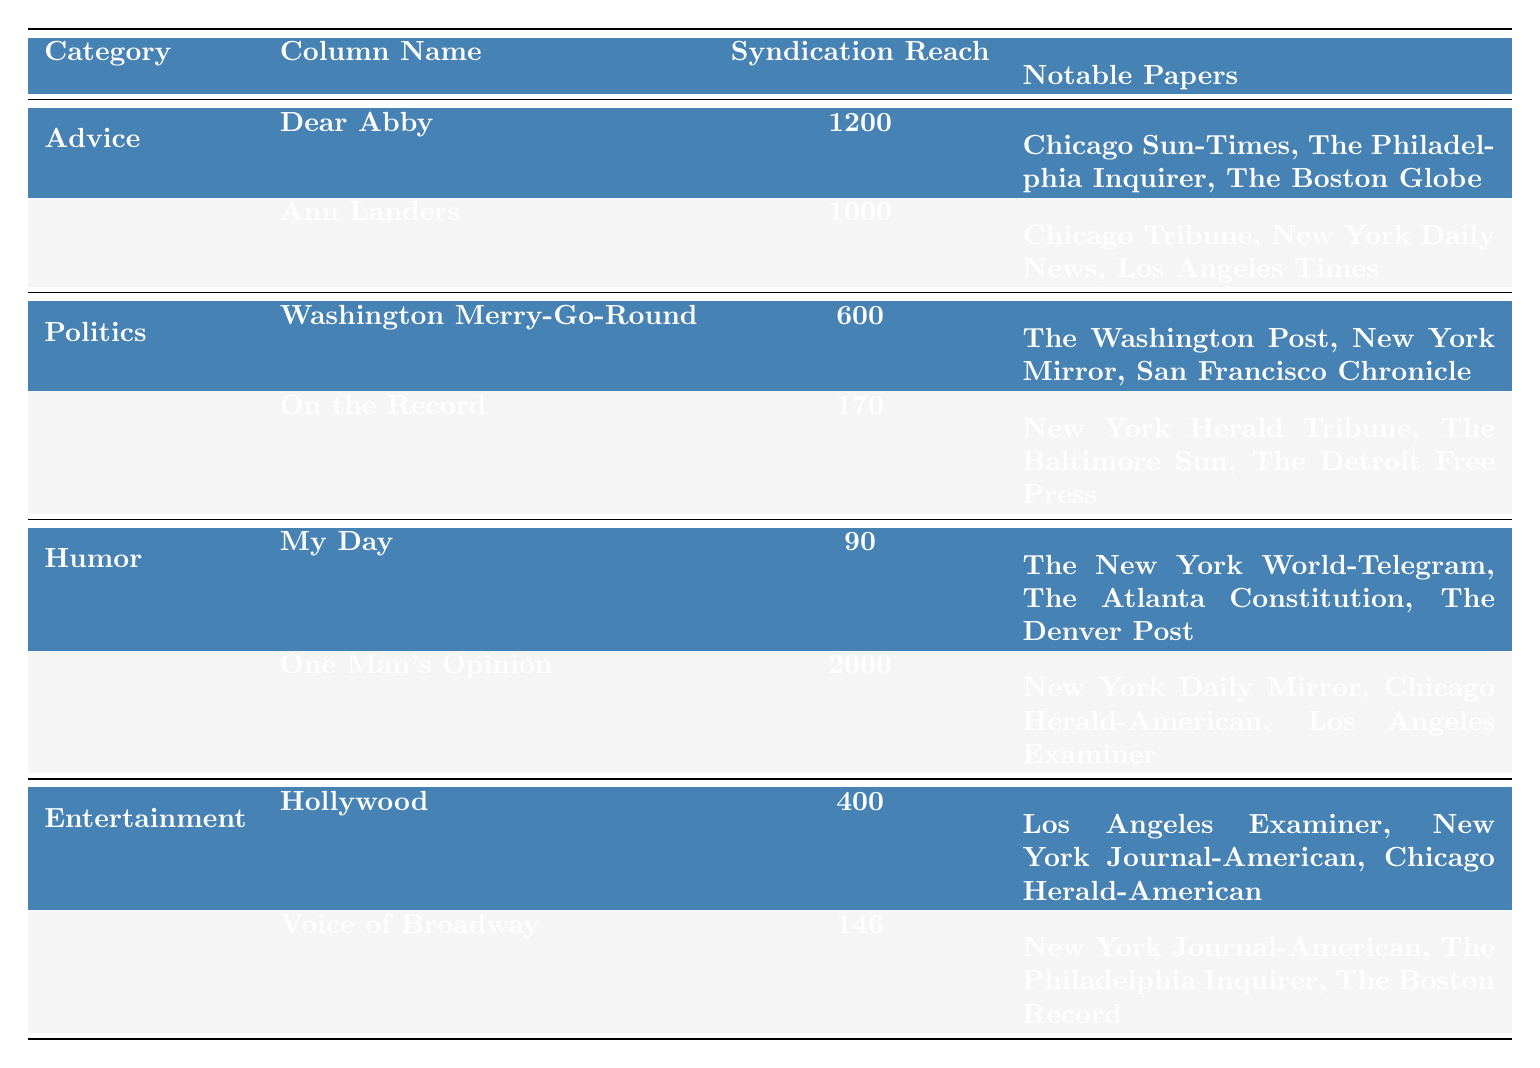What is the syndication reach of "Dear Abby"? From the table, the syndication reach for "Dear Abby" is listed directly as 1200.
Answer: 1200 Which column has the highest syndication reach? By comparing the values in the "Syndication Reach" column, "One Man's Opinion" has the highest at 2000.
Answer: One Man's Opinion How many notable papers are associated with "Washington Merry-Go-Round"? The table lists three notable papers for "Washington Merry-Go-Round": The Washington Post, New York Mirror, San Francisco Chronicle.
Answer: 3 Is "Ann Landers" listed under the Humor category? Referring to the categories in the table, "Ann Landers" is listed under the Advice category, not Humor.
Answer: No What is the difference in syndication reach between "My Day" and "Voice of Broadway"? "My Day" has a reach of 90, and "Voice of Broadway" has 146. The difference is 146 - 90 = 56.
Answer: 56 Which category has the lowest total syndication reach? To find this, sum the syndication reach for each category: Advice (2200), Politics (770), Humor (2090), Entertainment (546). The lowest is Politics with 770.
Answer: Politics List the authors of the columns with a syndication reach over 1000. The columns with a reach over 1000 are "Dear Abby" (Pauline Phillips) and "One Man's Opinion" (Walter Winchell).
Answer: Pauline Phillips, Walter Winchell What’s the average syndication reach of all columns listed in the table? First, add the syndication reaches: 1200 + 1000 + 600 + 170 + 90 + 2000 + 400 + 146 = 4706. There are 8 columns, so the average is 4706 / 8 = 588.25.
Answer: 588.25 Which author has the most notable papers listed? Count the notable papers for each author: Pauline Phillips (3), Eppie Lederer (3), Drew Pearson (3), Dorothy Thompson (3), Eleanor Roosevelt (3), Walter Winchell (3), Louella Parsons (3), Dorothy Kilgallen (3). All authors have 3, which is the maximum.
Answer: Tie (all 3) How many categories have a syndication reach greater than 1000? The Advice category has a total reach of 2200, and the Humor category has 2090. Thus, there are only 2 categories with a total reach greater than 1000.
Answer: 2 